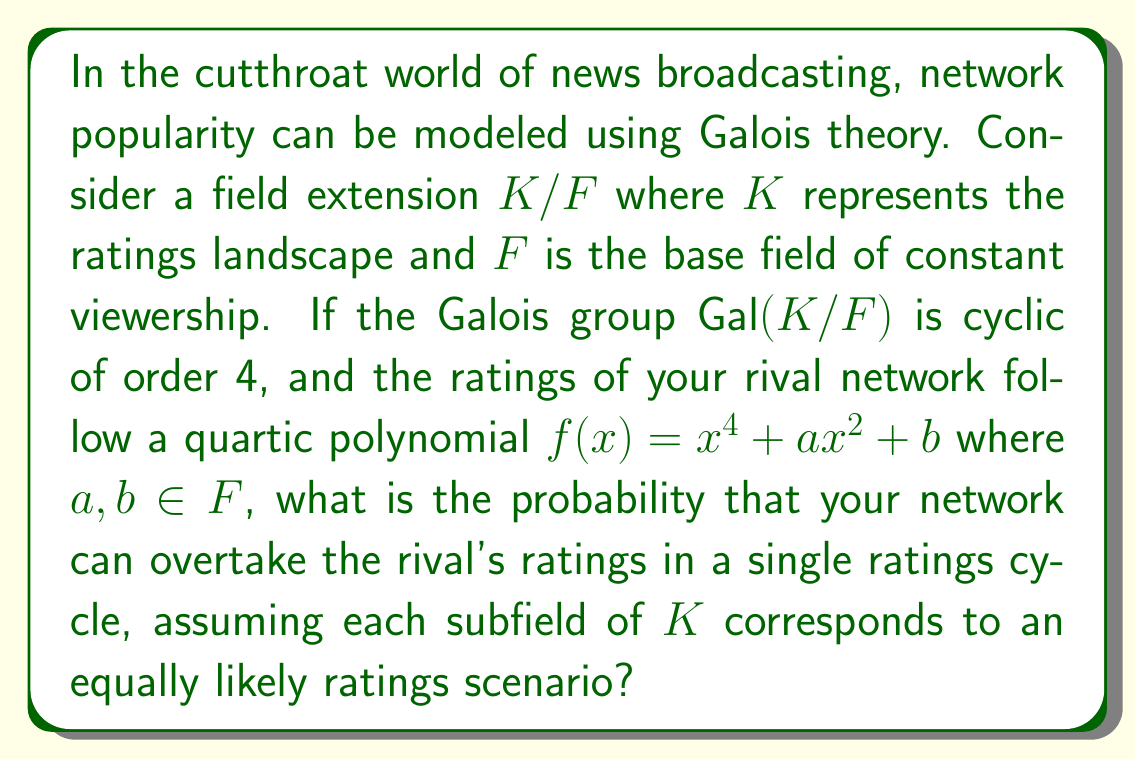Can you solve this math problem? Let's approach this step-by-step:

1) The Galois group $Gal(K/F)$ being cyclic of order 4 means that there are exactly 4 subfields between $K$ and $F$, including $K$ and $F$ themselves.

2) The intermediate fields form a chain: $F \subset E_1 \subset E_2 \subset K$, where $[K:E_2] = [E_2:E_1] = [E_1:F] = 2$.

3) The polynomial $f(x) = x^4 + ax^2 + b$ is a biquadratic polynomial. Its splitting field over $F$ is $K$.

4) The roots of $f(x)$ can be written as $\pm \sqrt{r_1}$ and $\pm \sqrt{r_2}$, where $r_1$ and $r_2$ are the roots of the quadratic equation $y^2 + ay + b = 0$.

5) The subfields correspond to:
   $E_1 = F(\sqrt{r_1})$
   $E_2 = F(\sqrt{r_1}, \sqrt{r_2})$
   $K = F(\sqrt{r_1}, \sqrt{r_2}, i)$

6) Each subfield represents a possible ratings scenario. To overtake the rival's ratings, we need to be in either $E_2$ or $K$, as these fields contain both $\sqrt{r_1}$ and $\sqrt{r_2}$.

7) Since there are 4 subfields in total, and each is equally likely, the probability of being in either $E_2$ or $K$ is 2/4 = 1/2.
Answer: $\frac{1}{2}$ 